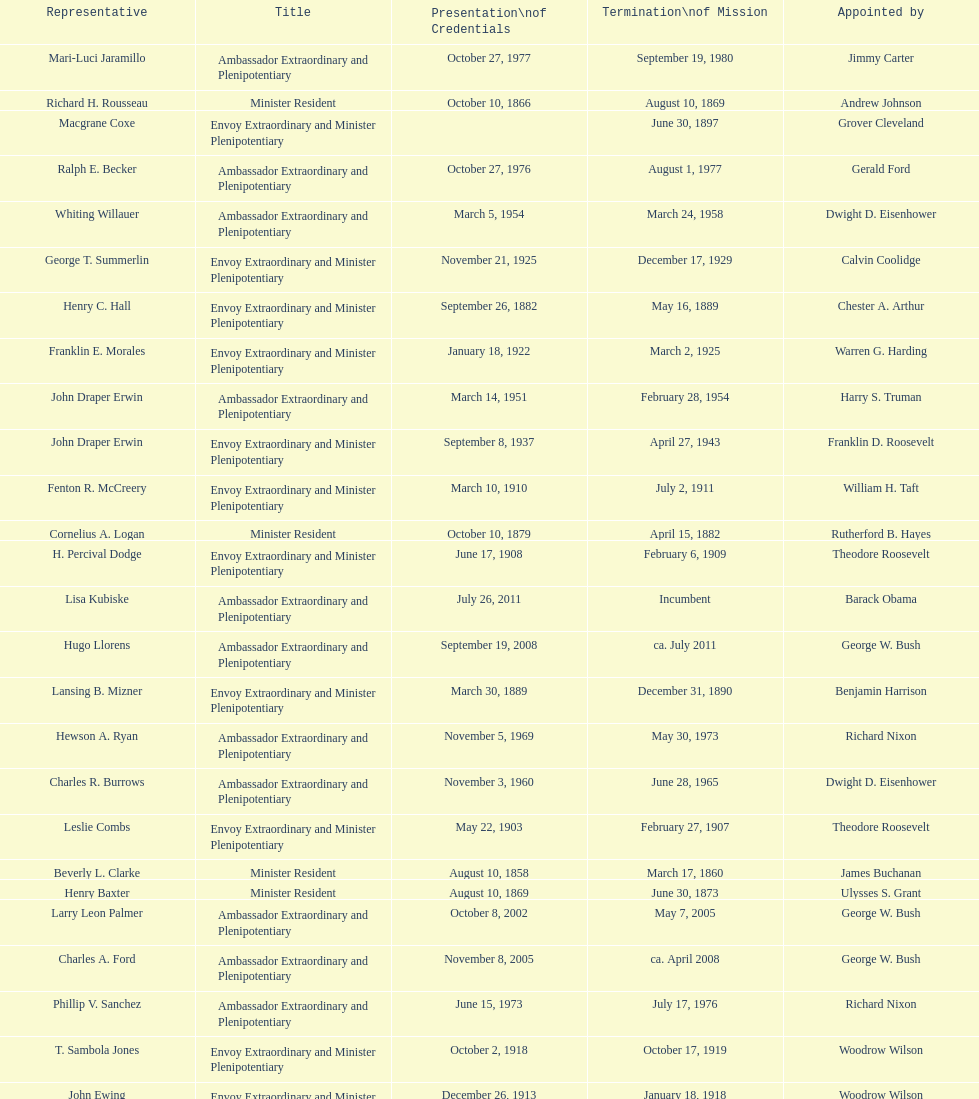Is solon borland a representative? Yes. 